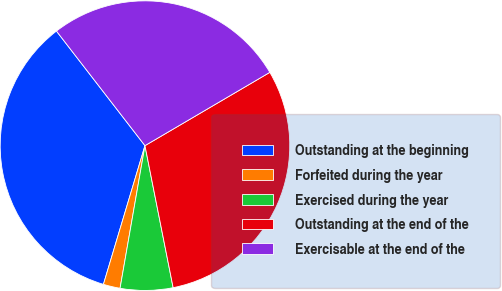Convert chart to OTSL. <chart><loc_0><loc_0><loc_500><loc_500><pie_chart><fcel>Outstanding at the beginning<fcel>Forfeited during the year<fcel>Exercised during the year<fcel>Outstanding at the end of the<fcel>Exercisable at the end of the<nl><fcel>34.9%<fcel>1.88%<fcel>5.87%<fcel>30.33%<fcel>27.02%<nl></chart> 